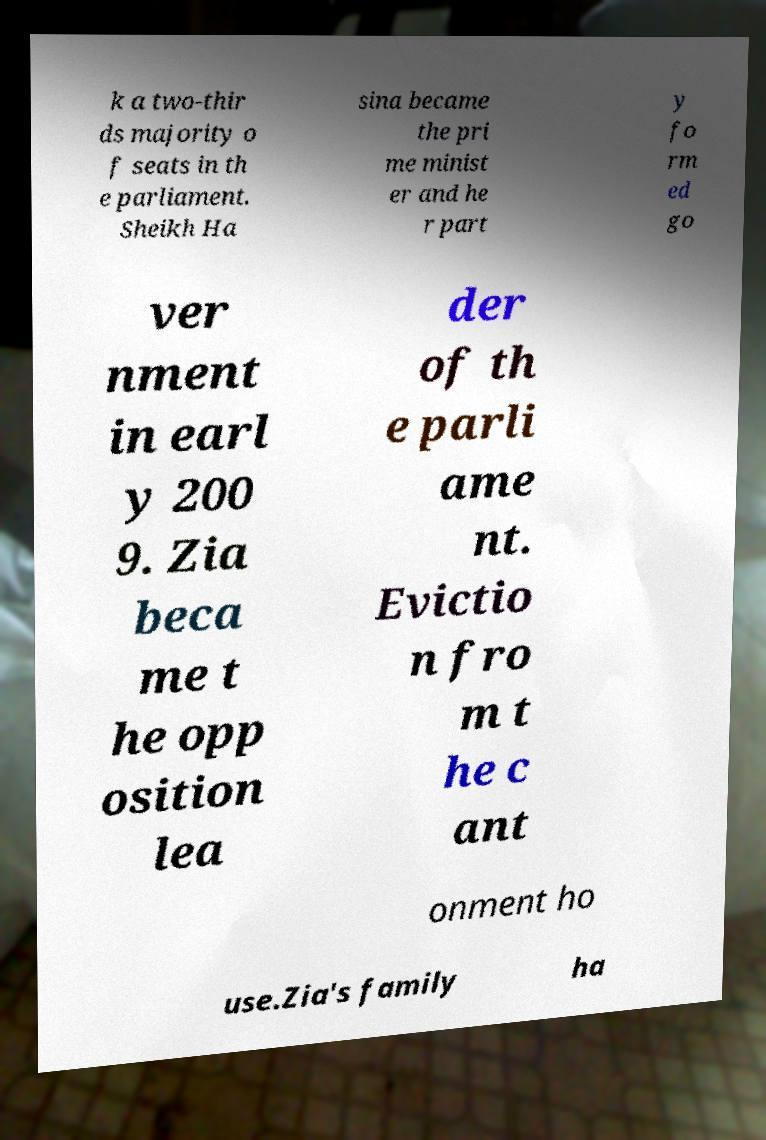Can you accurately transcribe the text from the provided image for me? k a two-thir ds majority o f seats in th e parliament. Sheikh Ha sina became the pri me minist er and he r part y fo rm ed go ver nment in earl y 200 9. Zia beca me t he opp osition lea der of th e parli ame nt. Evictio n fro m t he c ant onment ho use.Zia's family ha 